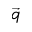Convert formula to latex. <formula><loc_0><loc_0><loc_500><loc_500>\vec { q }</formula> 